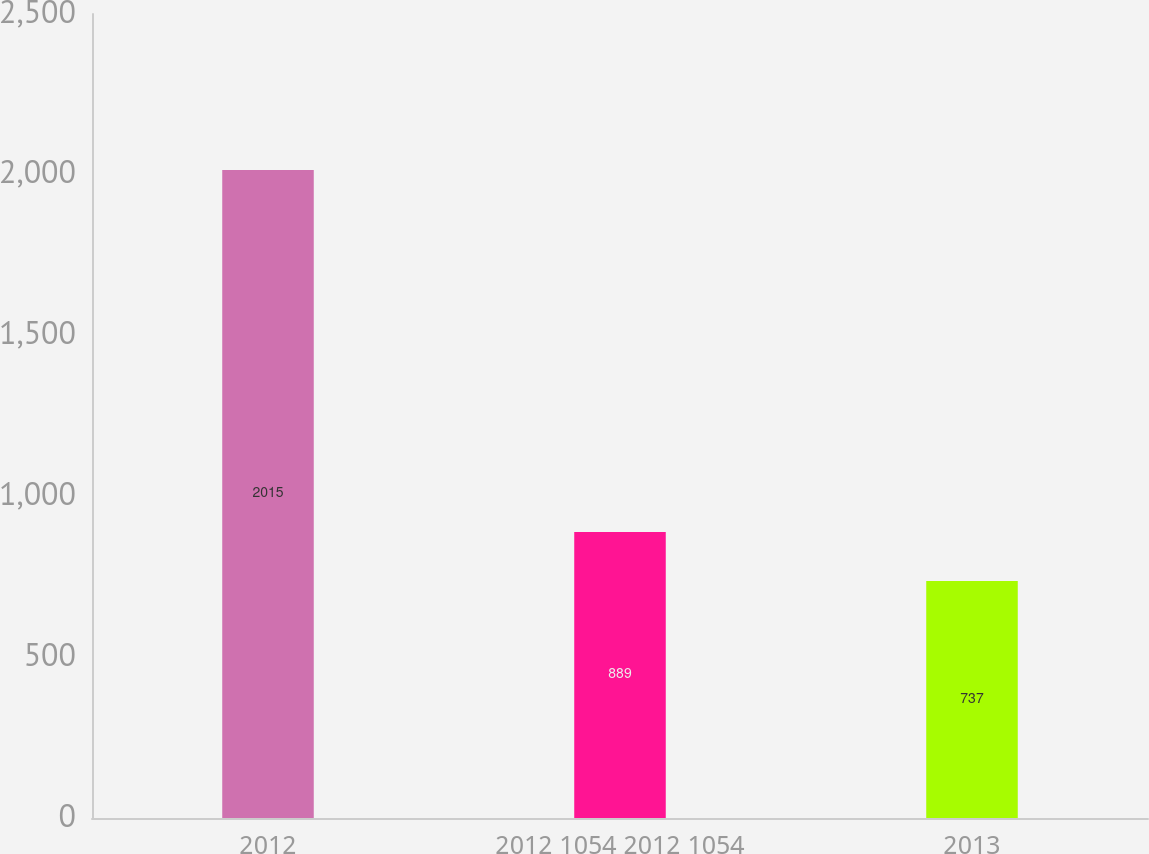<chart> <loc_0><loc_0><loc_500><loc_500><bar_chart><fcel>2012<fcel>2012 1054 2012 1054<fcel>2013<nl><fcel>2015<fcel>889<fcel>737<nl></chart> 